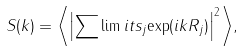Convert formula to latex. <formula><loc_0><loc_0><loc_500><loc_500>S ( { k } ) = { \left < \left | \sum \lim i t s _ { j } { \exp ( i { k R } _ { j } ) } \right | ^ { 2 } \right > } ,</formula> 